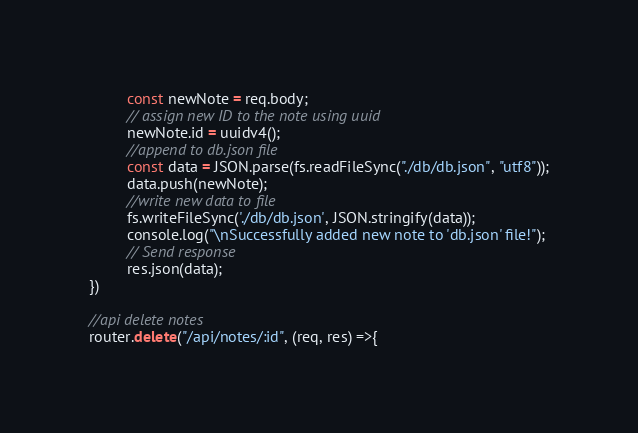<code> <loc_0><loc_0><loc_500><loc_500><_JavaScript_>         const newNote = req.body;
         // assign new ID to the note using uuid 
         newNote.id = uuidv4();
         //append to db.json file
         const data = JSON.parse(fs.readFileSync("./db/db.json", "utf8"));
         data.push(newNote);
         //write new data to file       
         fs.writeFileSync('./db/db.json', JSON.stringify(data));
         console.log("\nSuccessfully added new note to 'db.json' file!");
         // Send response
         res.json(data);
})

//api delete notes 
router.delete("/api/notes/:id", (req, res) =>{</code> 